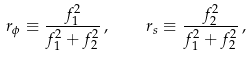Convert formula to latex. <formula><loc_0><loc_0><loc_500><loc_500>r _ { \phi } \equiv \frac { f _ { 1 } ^ { 2 } } { f _ { 1 } ^ { 2 } + f _ { 2 } ^ { 2 } } \, , \quad r _ { s } \equiv \frac { f _ { 2 } ^ { 2 } } { f _ { 1 } ^ { 2 } + f _ { 2 } ^ { 2 } } \, ,</formula> 